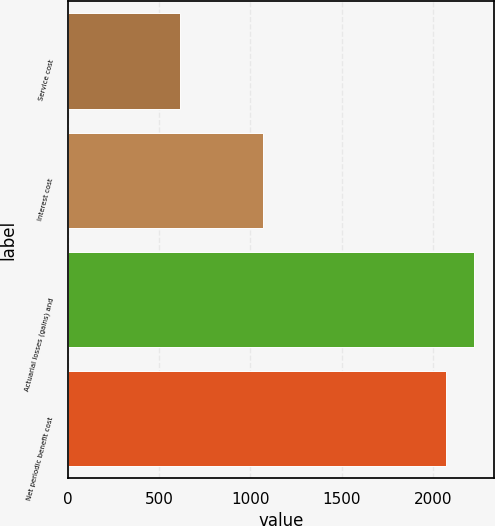<chart> <loc_0><loc_0><loc_500><loc_500><bar_chart><fcel>Service cost<fcel>Interest cost<fcel>Actuarial losses (gains) and<fcel>Net periodic benefit cost<nl><fcel>615<fcel>1068<fcel>2223.9<fcel>2070<nl></chart> 